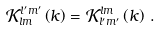<formula> <loc_0><loc_0><loc_500><loc_500>\mathcal { K } _ { l m } ^ { l ^ { \prime } m ^ { \prime } } \left ( k \right ) = \mathcal { K } _ { l ^ { \prime } m ^ { \prime } } ^ { l m } \left ( k \right ) \, .</formula> 